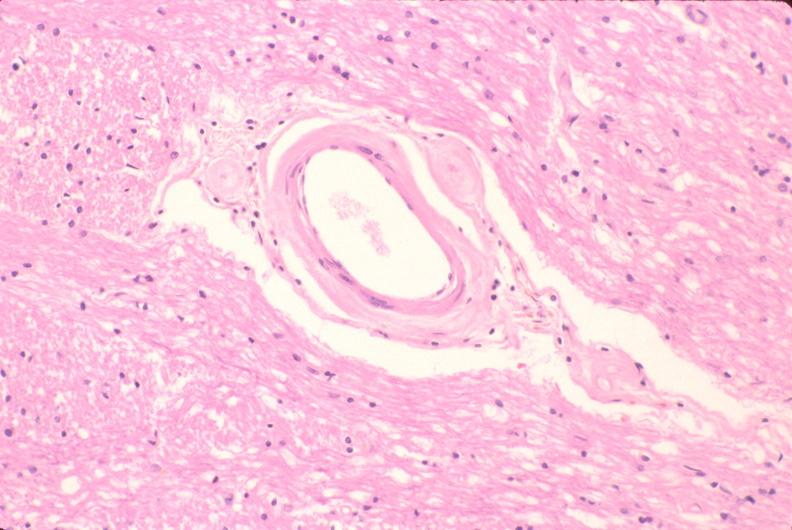where is this?
Answer the question using a single word or phrase. Nervous 